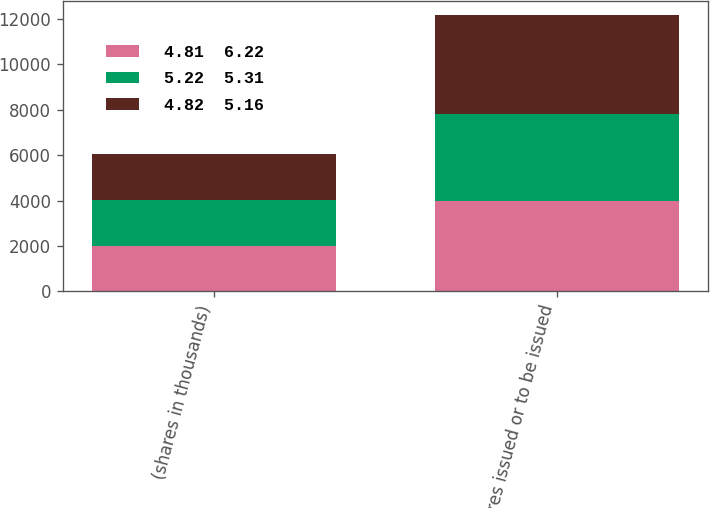Convert chart to OTSL. <chart><loc_0><loc_0><loc_500><loc_500><stacked_bar_chart><ecel><fcel>(shares in thousands)<fcel>Shares issued or to be issued<nl><fcel>4.81  6.22<fcel>2012<fcel>3979<nl><fcel>5.22  5.31<fcel>2011<fcel>3830<nl><fcel>4.82  5.16<fcel>2010<fcel>4358<nl></chart> 